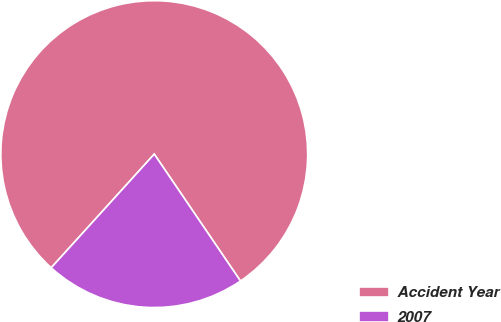<chart> <loc_0><loc_0><loc_500><loc_500><pie_chart><fcel>Accident Year<fcel>2007<nl><fcel>78.78%<fcel>21.22%<nl></chart> 